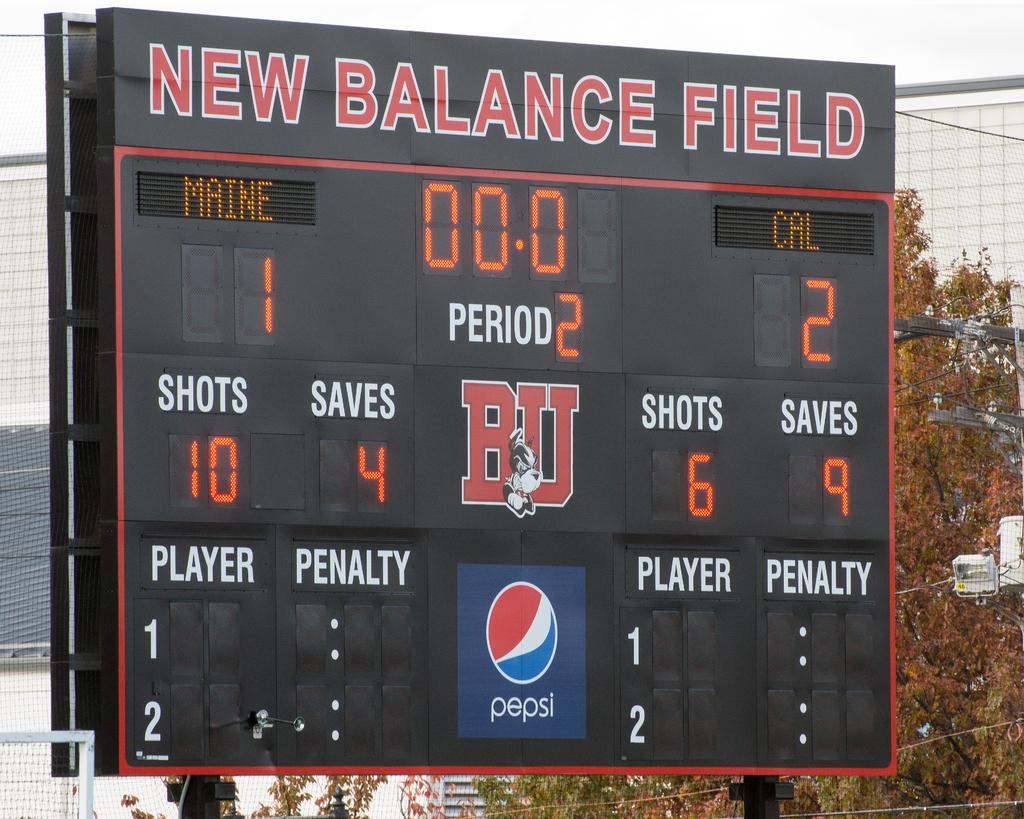<image>
Present a compact description of the photo's key features. The scoreboard at New Balance Field that shows period two. 